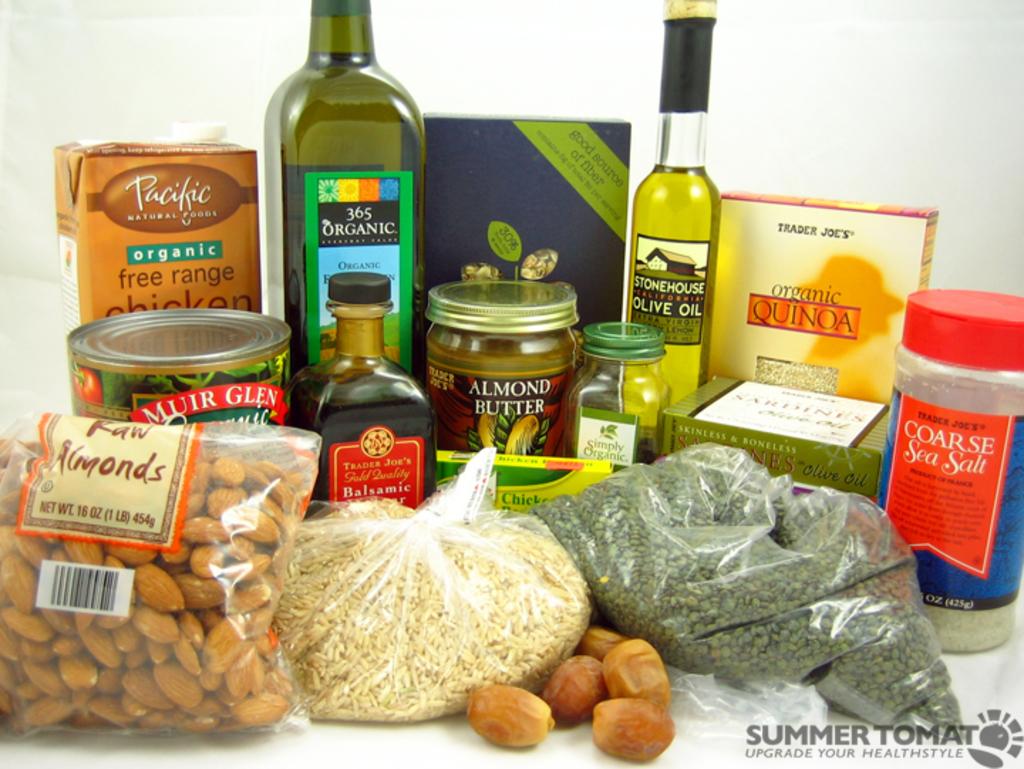Have the almonds been roasted?
Your answer should be very brief. No. What is the butter made from?
Your response must be concise. Almond. 